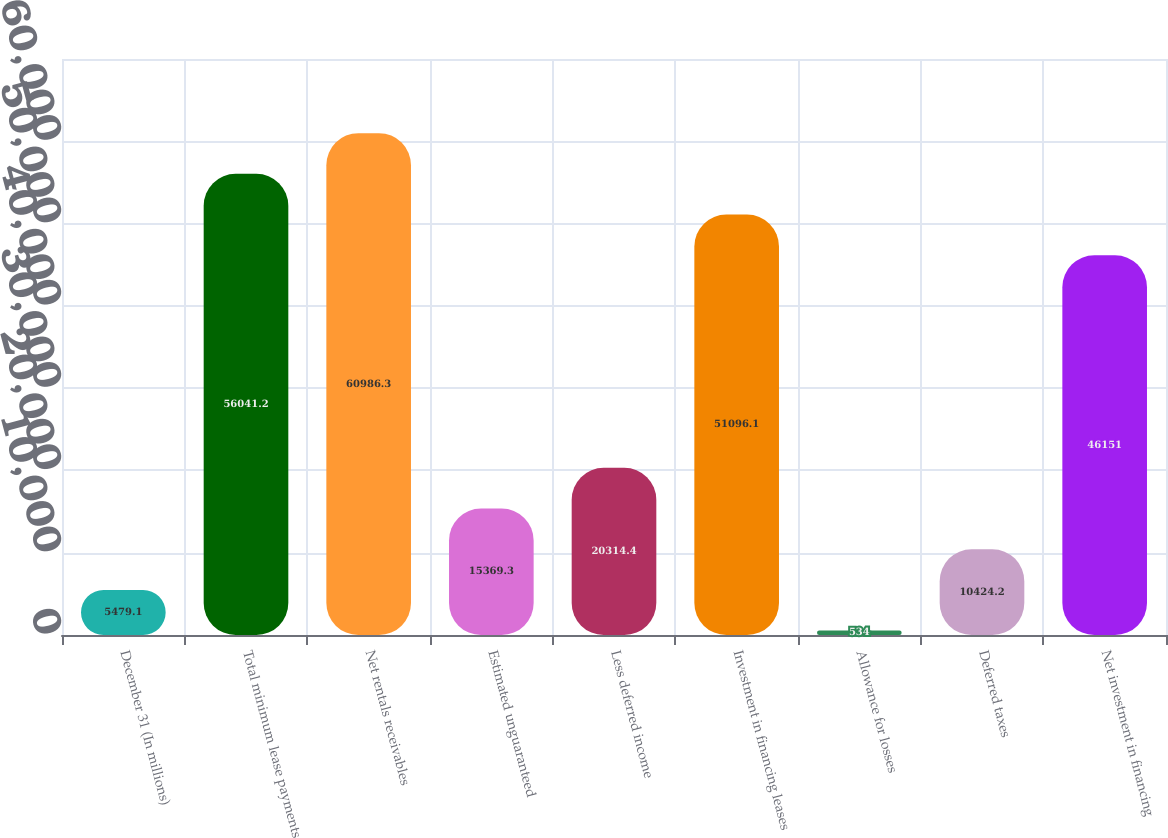<chart> <loc_0><loc_0><loc_500><loc_500><bar_chart><fcel>December 31 (In millions)<fcel>Total minimum lease payments<fcel>Net rentals receivables<fcel>Estimated unguaranteed<fcel>Less deferred income<fcel>Investment in financing leases<fcel>Allowance for losses<fcel>Deferred taxes<fcel>Net investment in financing<nl><fcel>5479.1<fcel>56041.2<fcel>60986.3<fcel>15369.3<fcel>20314.4<fcel>51096.1<fcel>534<fcel>10424.2<fcel>46151<nl></chart> 